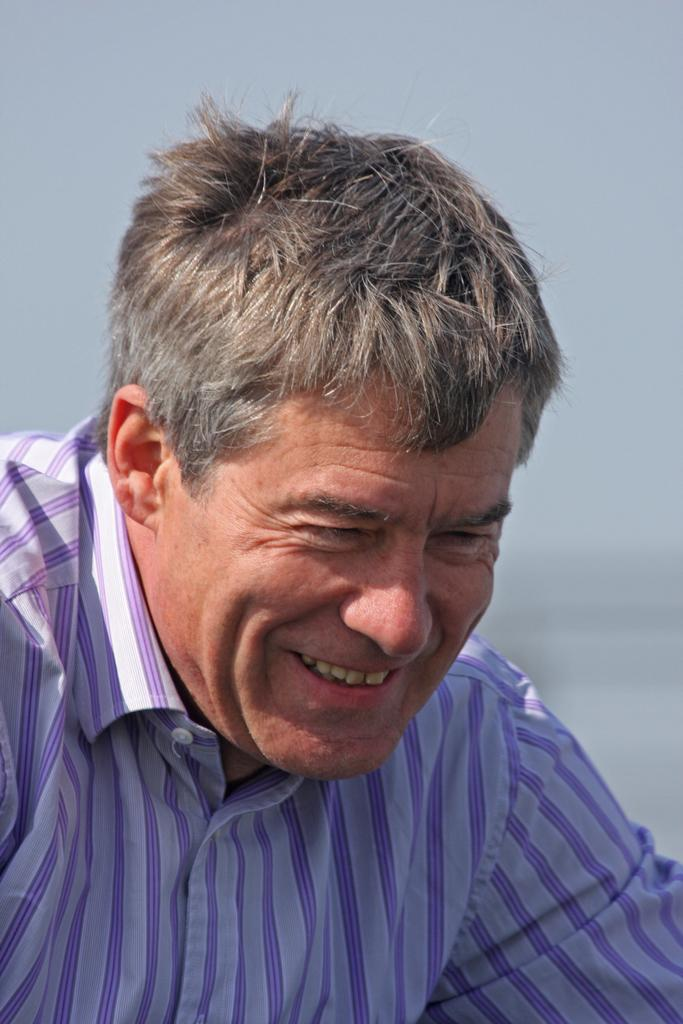What is the main subject of the image? There is a man in the image. What is the man doing in the image? The man is smiling in the image. What can be seen in the background of the image? The sky is visible in the background of the image. How fast is the man running in the image? The man is not running in the image; he is smiling. 